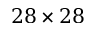Convert formula to latex. <formula><loc_0><loc_0><loc_500><loc_500>2 8 \times 2 8</formula> 